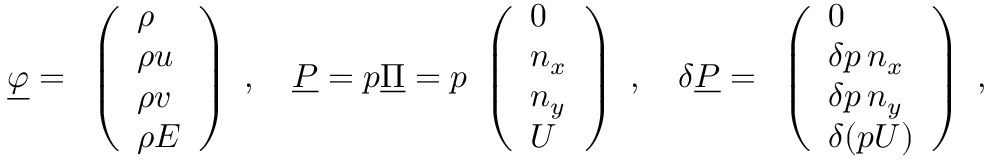Convert formula to latex. <formula><loc_0><loc_0><loc_500><loc_500>\underline { \varphi } = \begin{array} { l } { \left ( \begin{array} { l } { \rho } \\ { \rho u } \\ { \rho v } \\ { \rho E } \end{array} \right ) } \end{array} , \quad \underline { P } = p \underline { \Pi } = p \begin{array} { l } { \left ( \begin{array} { l } { 0 } \\ { n _ { x } } \\ { n _ { y } } \\ { U } \end{array} \right ) } \end{array} , \quad \delta \underline { P } = \begin{array} { l } { \left ( \begin{array} { l } { 0 } \\ { \delta p \, n _ { x } } \\ { \delta p \, n _ { y } } \\ { \delta ( p U ) } \end{array} \right ) } \end{array} ,</formula> 